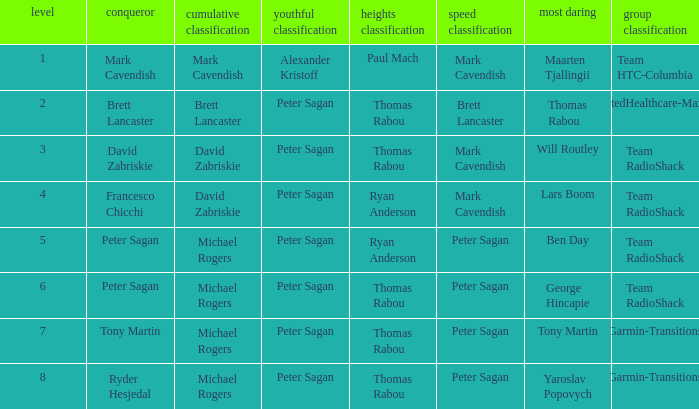When mark cavendish is the sprint classification winner and maarten tjallingii is recognized as the most courageous, who is the victor in the youth classification? Alexander Kristoff. 